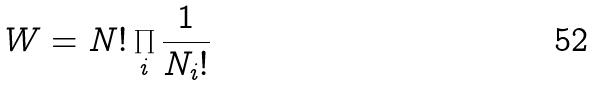<formula> <loc_0><loc_0><loc_500><loc_500>W = N ! \prod _ { i } \frac { 1 } { N _ { i } ! }</formula> 